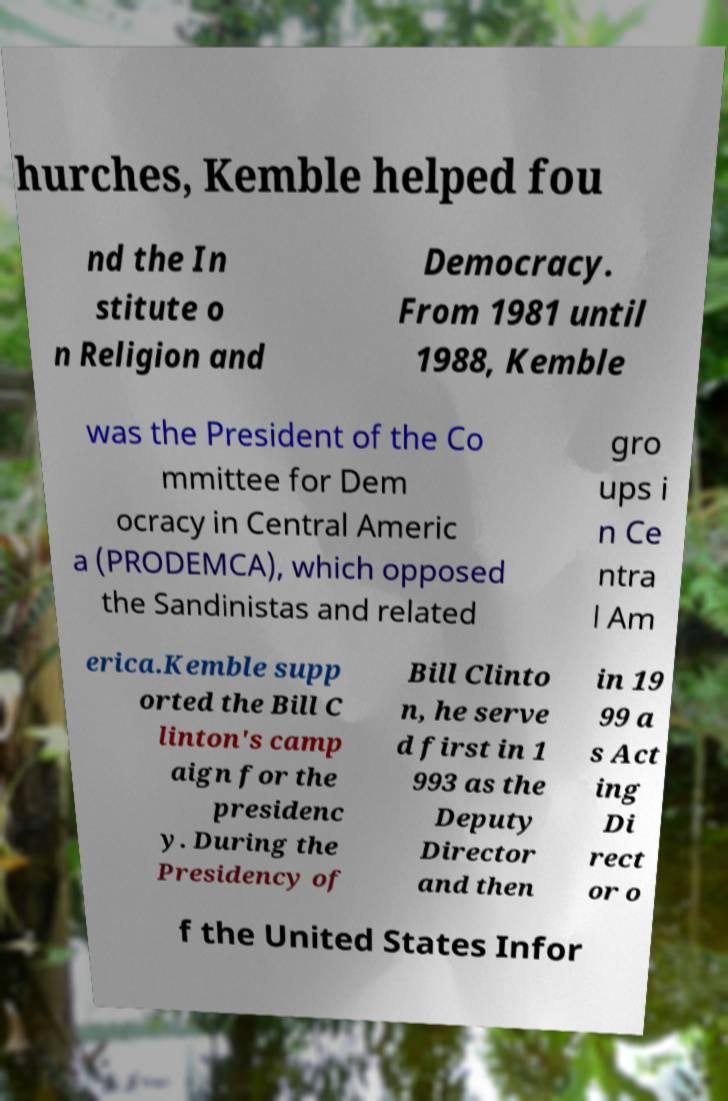There's text embedded in this image that I need extracted. Can you transcribe it verbatim? hurches, Kemble helped fou nd the In stitute o n Religion and Democracy. From 1981 until 1988, Kemble was the President of the Co mmittee for Dem ocracy in Central Americ a (PRODEMCA), which opposed the Sandinistas and related gro ups i n Ce ntra l Am erica.Kemble supp orted the Bill C linton's camp aign for the presidenc y. During the Presidency of Bill Clinto n, he serve d first in 1 993 as the Deputy Director and then in 19 99 a s Act ing Di rect or o f the United States Infor 